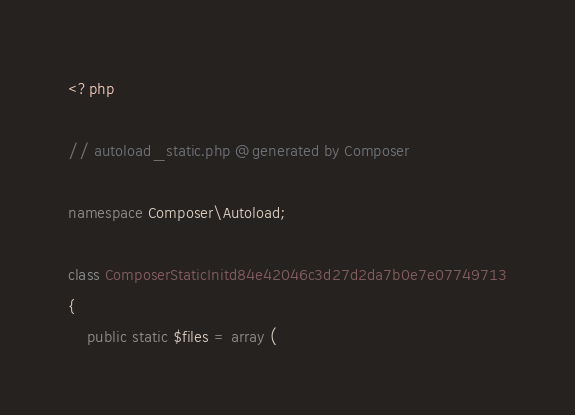<code> <loc_0><loc_0><loc_500><loc_500><_PHP_><?php

// autoload_static.php @generated by Composer

namespace Composer\Autoload;

class ComposerStaticInitd84e42046c3d27d2da7b0e7e07749713
{
    public static $files = array (</code> 